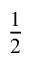Convert formula to latex. <formula><loc_0><loc_0><loc_500><loc_500>\frac { 1 } { 2 }</formula> 